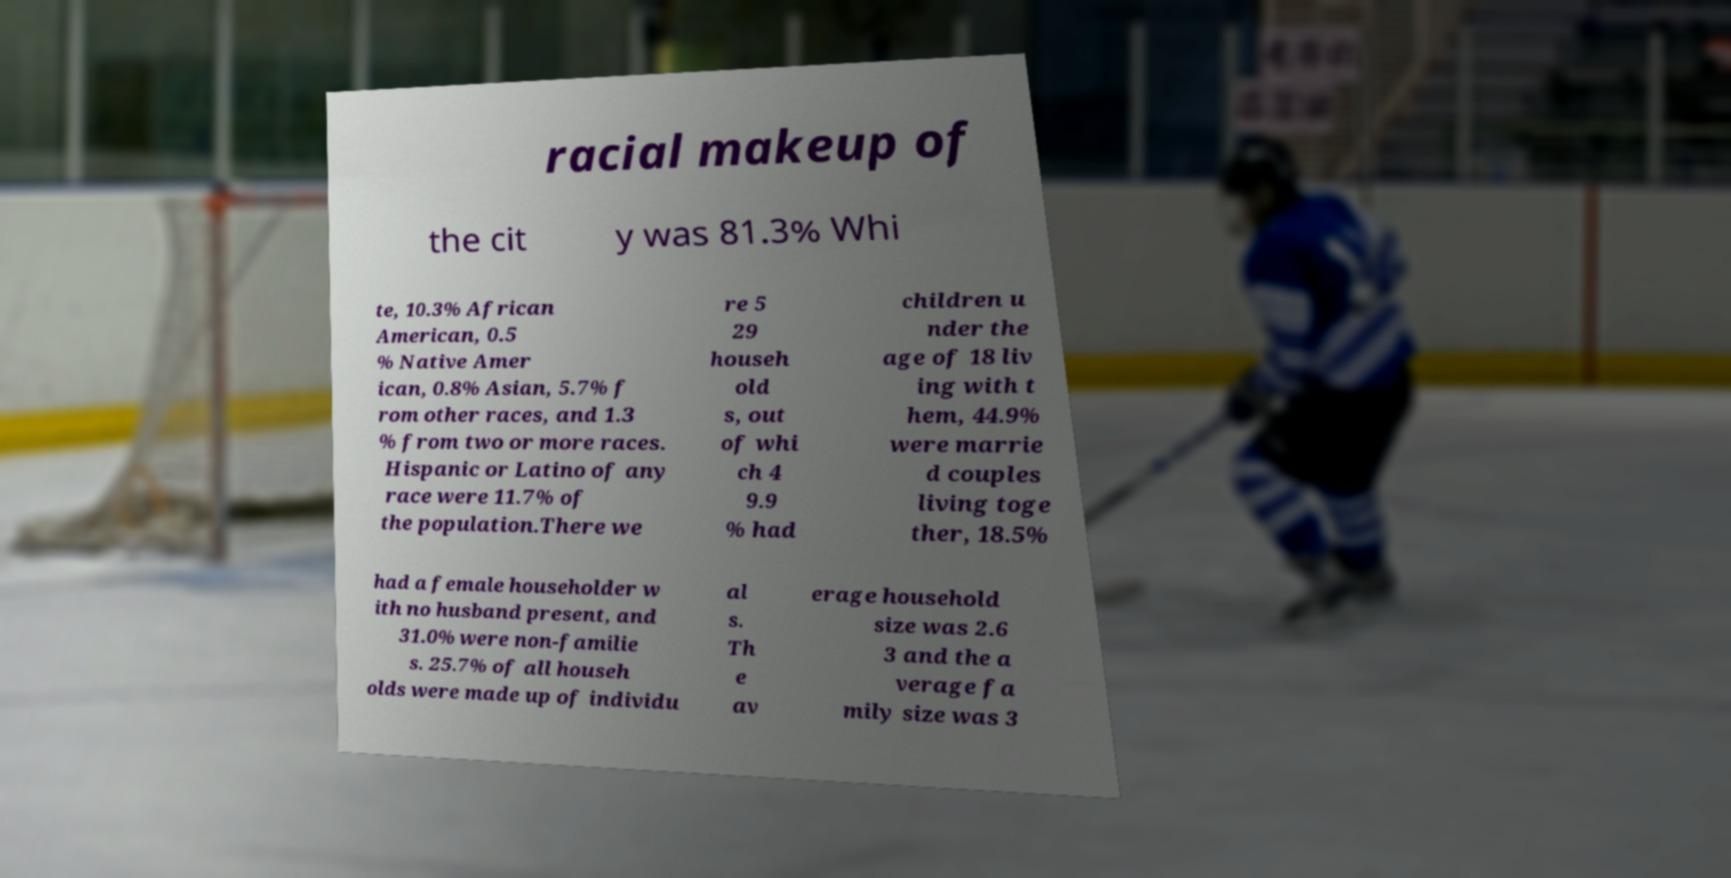I need the written content from this picture converted into text. Can you do that? racial makeup of the cit y was 81.3% Whi te, 10.3% African American, 0.5 % Native Amer ican, 0.8% Asian, 5.7% f rom other races, and 1.3 % from two or more races. Hispanic or Latino of any race were 11.7% of the population.There we re 5 29 househ old s, out of whi ch 4 9.9 % had children u nder the age of 18 liv ing with t hem, 44.9% were marrie d couples living toge ther, 18.5% had a female householder w ith no husband present, and 31.0% were non-familie s. 25.7% of all househ olds were made up of individu al s. Th e av erage household size was 2.6 3 and the a verage fa mily size was 3 